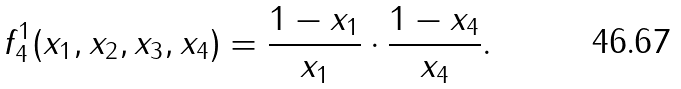Convert formula to latex. <formula><loc_0><loc_0><loc_500><loc_500>f _ { 4 } ^ { 1 } ( x _ { 1 } , x _ { 2 } , x _ { 3 } , x _ { 4 } ) = \frac { 1 - x _ { 1 } } { x _ { 1 } } \cdot \frac { 1 - x _ { 4 } } { x _ { 4 } } .</formula> 